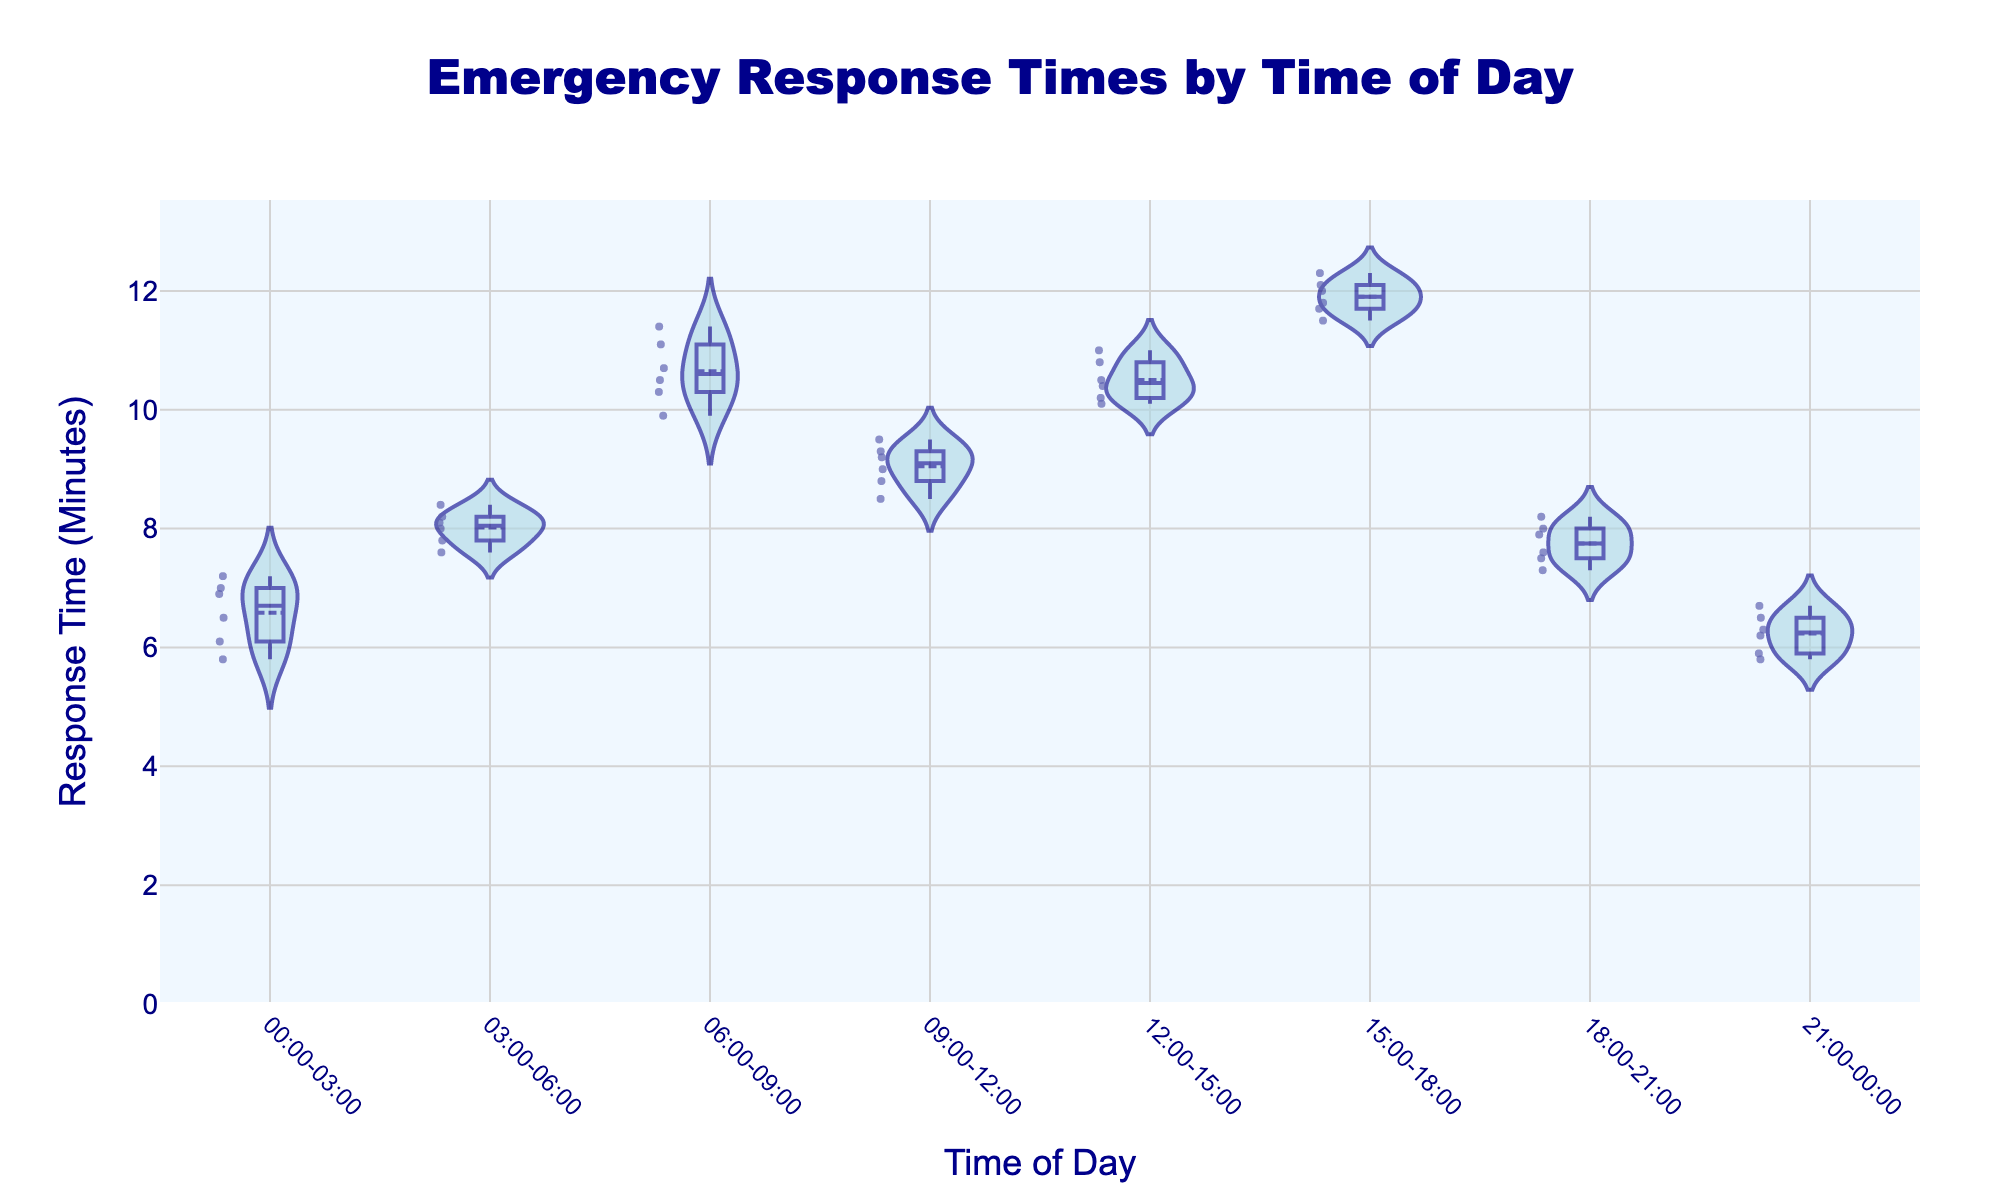what is the title of the figure? The title of the figure is displayed prominently at the top center of the plot in large, bold-faced font.
Answer: Emergency Response Times by Time of Day What is the range of response times in the 03:00-06:00 time period? To find the range, look at the lowest and the highest data points within the 03:00-06:00 time period. The lowest point is 7.6 minutes, and the highest is 8.4 minutes.
Answer: 7.6 to 8.4 minutes Which time period has the highest median response time? The median response time is shown by the central line within the box of the overlay box plot. The 15:00-18:00 time period has the highest median response time.
Answer: 15:00-18:00 During which time period is there the most variation in response times? The most variation can be identified by the widest spread within the violin plot. The 06:00-09:00 period shows the widest spread, indicating the most variation in response times.
Answer: 06:00-09:00 How does the mean response time of 12:00-15:00 compare to 21:00-00:00? Look at the mean lines within each violin plot to compare means. 12:00-15:00 has a higher mean response time than 21:00-00:00.
Answer: 12:00-15:00 is higher Which time period has the smallest lower whisker in the box plot overlay? The smallest lower whisker is identified by the lower end of the box plot whiskers. The 21:00-00:00 period has the smallest lower whisker.
Answer: 21:00-00:00 Are responses more consistent during 03:00-06:00 or 18:00-21:00? Consistency can be judged by the narrowness of the violin plot, meaning less spread in response times. 18:00-21:00 shows more consistency due to a narrower spread.
Answer: 18:00-21:00 What is the interquartile range (IQR) for the 09:00-12:00 time period? The IQR is the range of the central 50% of the data points, shown by the box within the box plot. Calculate the difference between the upper and lower quartiles. For 09:00-12:00, the IQR is from 8.8 to 9.5 minutes, so IQR = 9.5 - 8.8.
Answer: 0.7 minutes Which time periods show any outliers in response times? Outliers are often marked by individual points outside the whiskers of the box plot. There are no visible outliers marked in any of the time periods.
Answer: None 